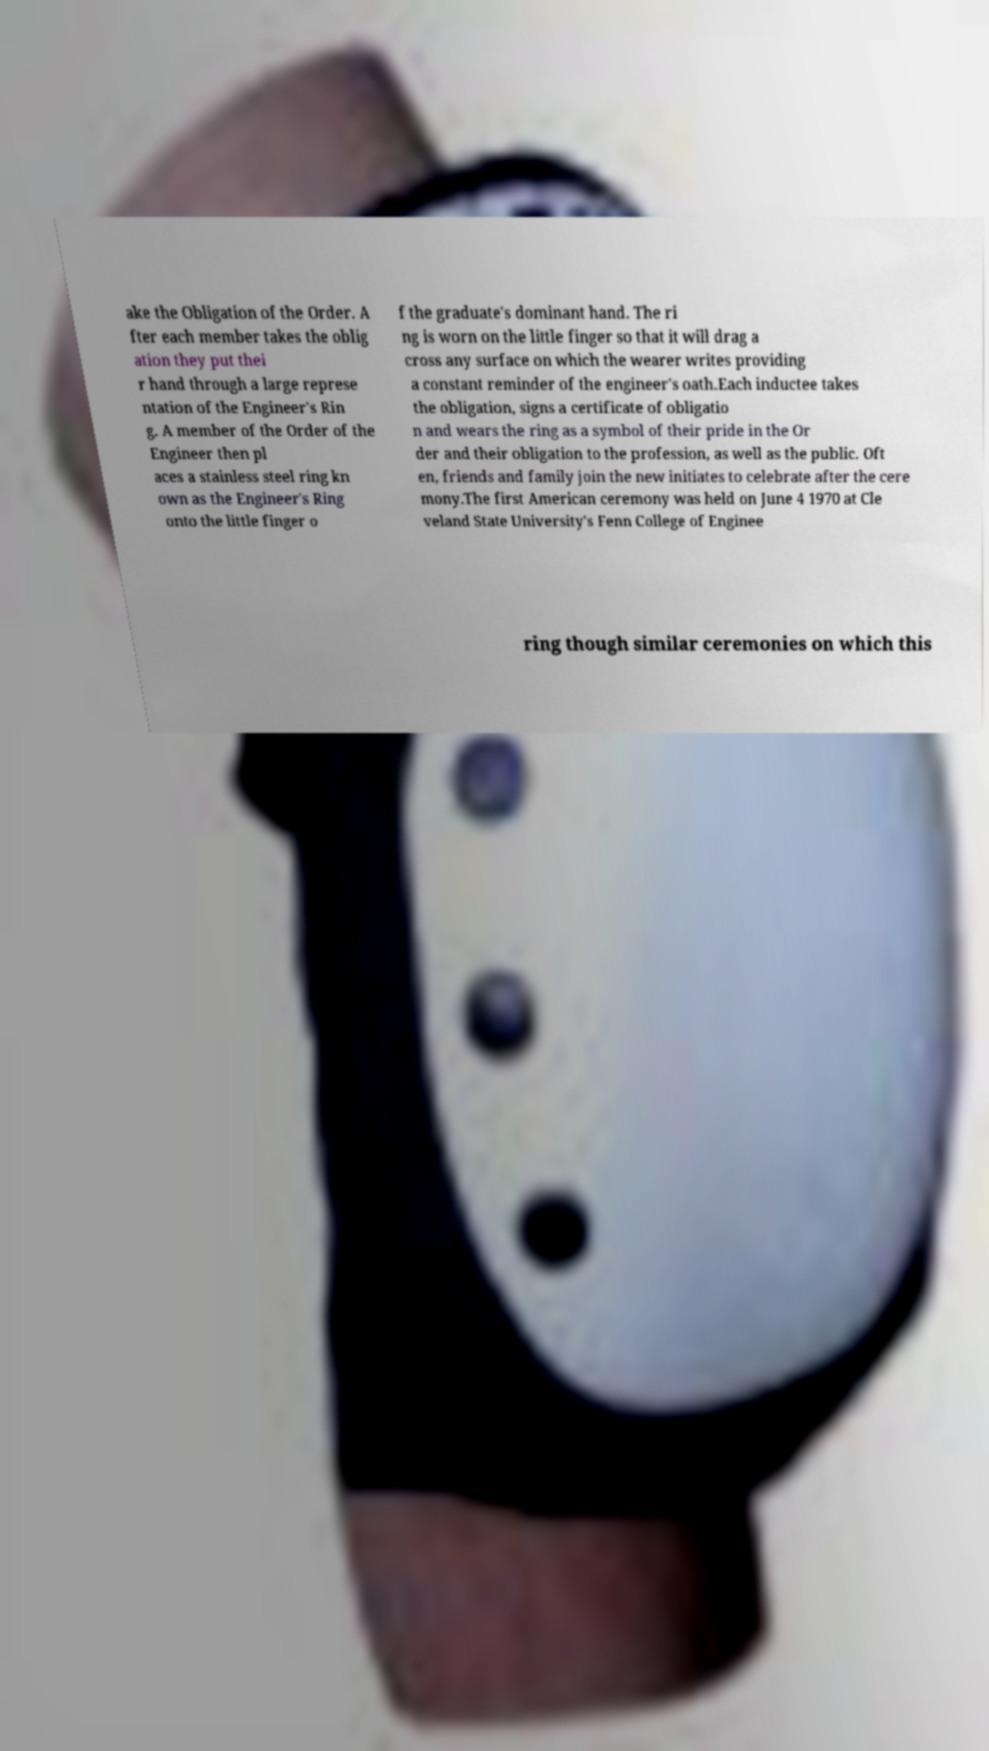Could you extract and type out the text from this image? ake the Obligation of the Order. A fter each member takes the oblig ation they put thei r hand through a large represe ntation of the Engineer's Rin g. A member of the Order of the Engineer then pl aces a stainless steel ring kn own as the Engineer's Ring onto the little finger o f the graduate's dominant hand. The ri ng is worn on the little finger so that it will drag a cross any surface on which the wearer writes providing a constant reminder of the engineer's oath.Each inductee takes the obligation, signs a certificate of obligatio n and wears the ring as a symbol of their pride in the Or der and their obligation to the profession, as well as the public. Oft en, friends and family join the new initiates to celebrate after the cere mony.The first American ceremony was held on June 4 1970 at Cle veland State University's Fenn College of Enginee ring though similar ceremonies on which this 